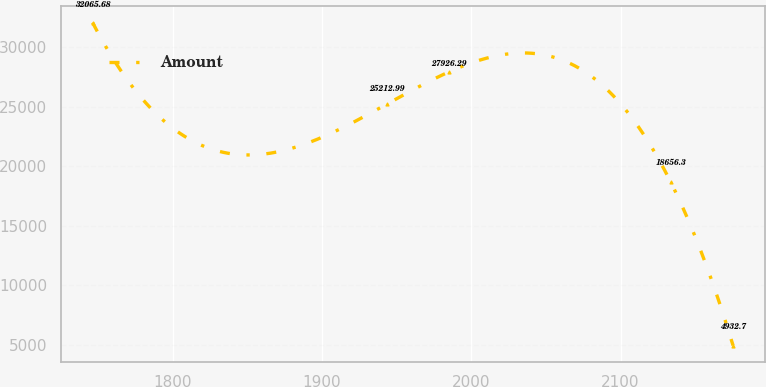Convert chart. <chart><loc_0><loc_0><loc_500><loc_500><line_chart><ecel><fcel>Amount<nl><fcel>1746.34<fcel>32065.7<nl><fcel>1943.4<fcel>25213<nl><fcel>1985.12<fcel>27926.3<nl><fcel>2133.65<fcel>18656.3<nl><fcel>2175.37<fcel>4932.7<nl></chart> 